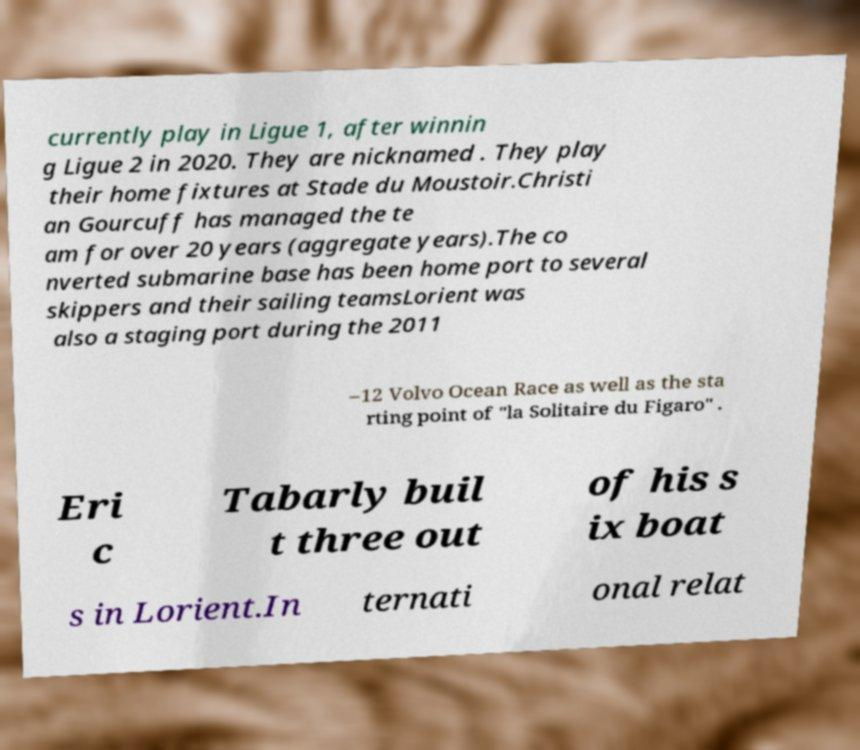Please read and relay the text visible in this image. What does it say? currently play in Ligue 1, after winnin g Ligue 2 in 2020. They are nicknamed . They play their home fixtures at Stade du Moustoir.Christi an Gourcuff has managed the te am for over 20 years (aggregate years).The co nverted submarine base has been home port to several skippers and their sailing teamsLorient was also a staging port during the 2011 –12 Volvo Ocean Race as well as the sta rting point of "la Solitaire du Figaro" . Eri c Tabarly buil t three out of his s ix boat s in Lorient.In ternati onal relat 